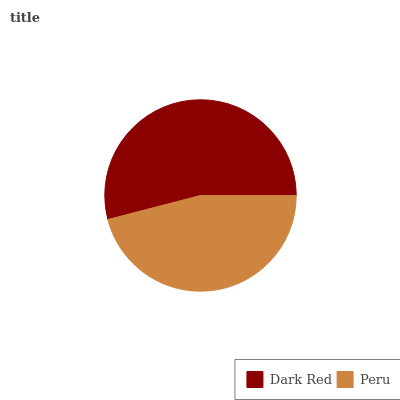Is Peru the minimum?
Answer yes or no. Yes. Is Dark Red the maximum?
Answer yes or no. Yes. Is Peru the maximum?
Answer yes or no. No. Is Dark Red greater than Peru?
Answer yes or no. Yes. Is Peru less than Dark Red?
Answer yes or no. Yes. Is Peru greater than Dark Red?
Answer yes or no. No. Is Dark Red less than Peru?
Answer yes or no. No. Is Dark Red the high median?
Answer yes or no. Yes. Is Peru the low median?
Answer yes or no. Yes. Is Peru the high median?
Answer yes or no. No. Is Dark Red the low median?
Answer yes or no. No. 